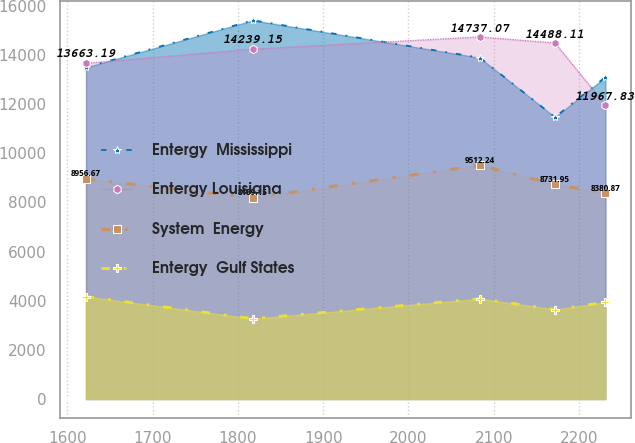Convert chart to OTSL. <chart><loc_0><loc_0><loc_500><loc_500><line_chart><ecel><fcel>Entergy  Mississippi<fcel>Entergy Louisiana<fcel>System  Energy<fcel>Entergy  Gulf States<nl><fcel>1621.97<fcel>13496.4<fcel>13663.2<fcel>8956.67<fcel>4172.81<nl><fcel>1817.8<fcel>15411.2<fcel>14239.1<fcel>8189.15<fcel>3270.13<nl><fcel>2083.58<fcel>13890.6<fcel>14737.1<fcel>9512.24<fcel>4083.07<nl><fcel>2171.82<fcel>11469.3<fcel>14488.1<fcel>8731.95<fcel>3643.13<nl><fcel>2230.97<fcel>13102.2<fcel>11967.8<fcel>8380.87<fcel>3936.03<nl></chart> 